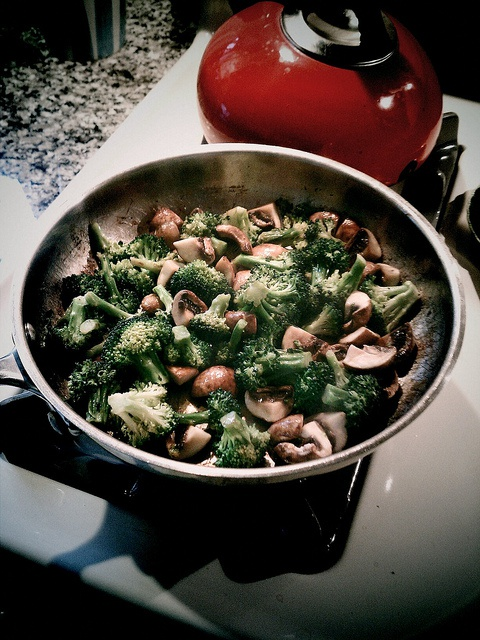Describe the objects in this image and their specific colors. I can see bowl in black, darkgreen, lightgray, and gray tones, broccoli in black, darkgreen, and olive tones, broccoli in black, darkgreen, and olive tones, broccoli in black, darkgreen, tan, and gray tones, and broccoli in black, darkgreen, and gray tones in this image. 